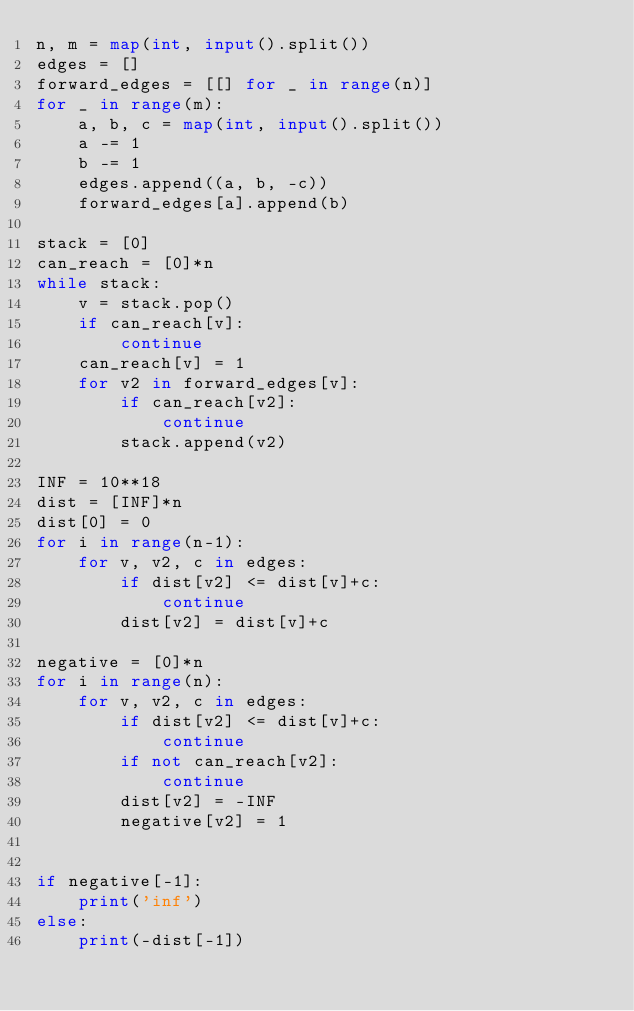<code> <loc_0><loc_0><loc_500><loc_500><_Python_>n, m = map(int, input().split())
edges = []
forward_edges = [[] for _ in range(n)]
for _ in range(m):
    a, b, c = map(int, input().split())
    a -= 1
    b -= 1
    edges.append((a, b, -c))
    forward_edges[a].append(b)

stack = [0]
can_reach = [0]*n
while stack:
    v = stack.pop()
    if can_reach[v]:
        continue
    can_reach[v] = 1
    for v2 in forward_edges[v]:
        if can_reach[v2]:
            continue
        stack.append(v2)

INF = 10**18
dist = [INF]*n
dist[0] = 0
for i in range(n-1):
    for v, v2, c in edges:
        if dist[v2] <= dist[v]+c:
            continue
        dist[v2] = dist[v]+c

negative = [0]*n
for i in range(n):
    for v, v2, c in edges:
        if dist[v2] <= dist[v]+c:
            continue
        if not can_reach[v2]:
            continue
        dist[v2] = -INF
        negative[v2] = 1


if negative[-1]:
    print('inf')
else:
    print(-dist[-1])</code> 